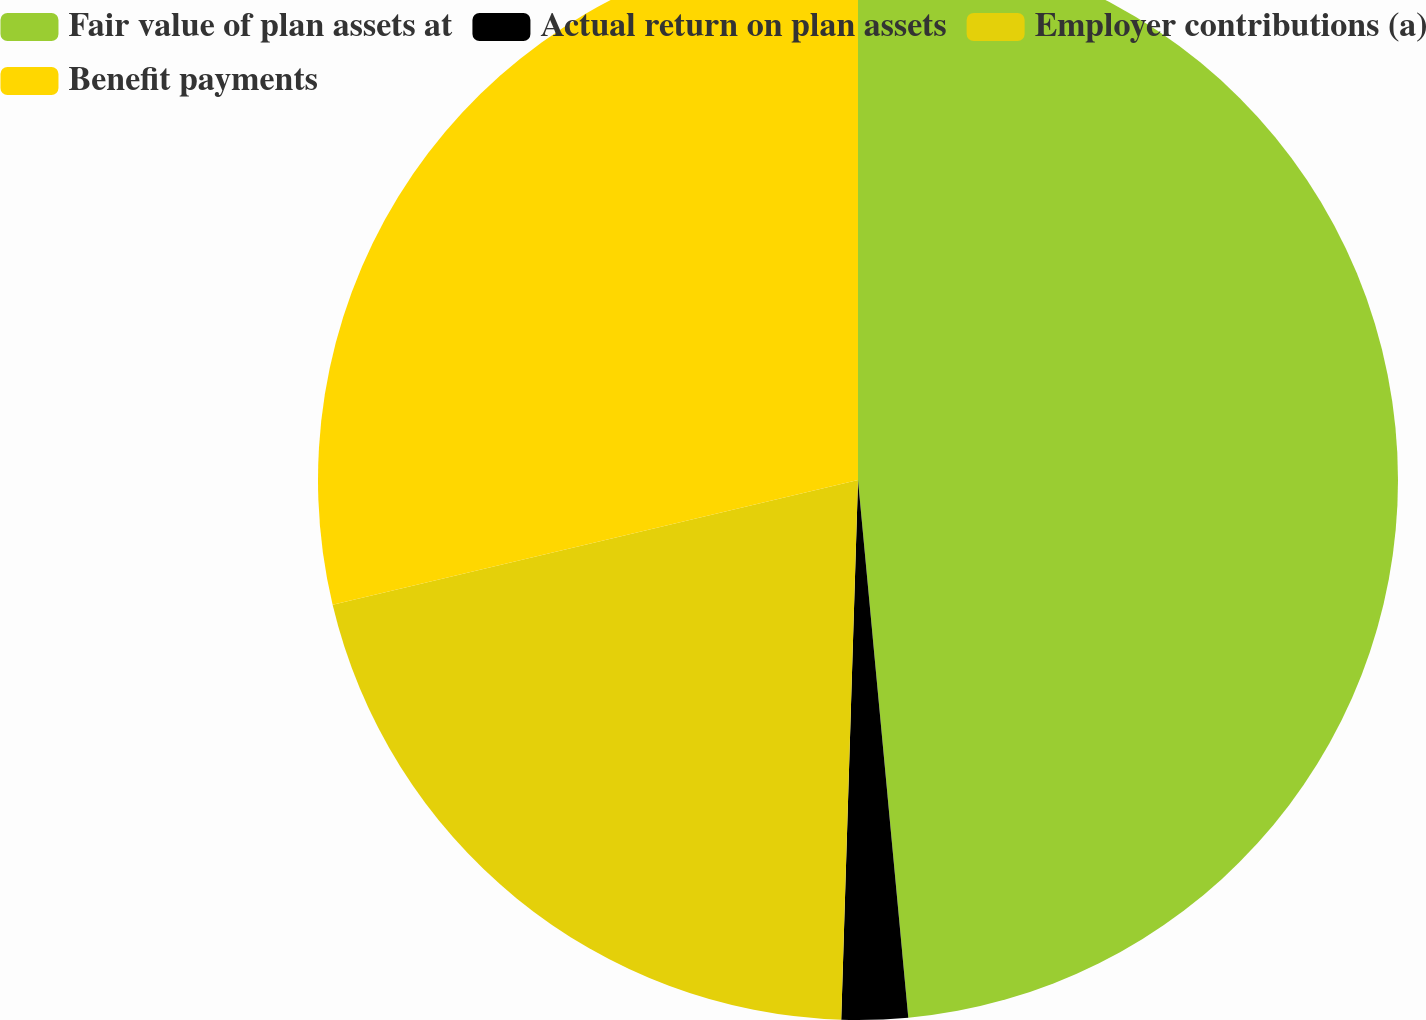Convert chart. <chart><loc_0><loc_0><loc_500><loc_500><pie_chart><fcel>Fair value of plan assets at<fcel>Actual return on plan assets<fcel>Employer contributions (a)<fcel>Benefit payments<nl><fcel>48.51%<fcel>1.98%<fcel>20.79%<fcel>28.71%<nl></chart> 